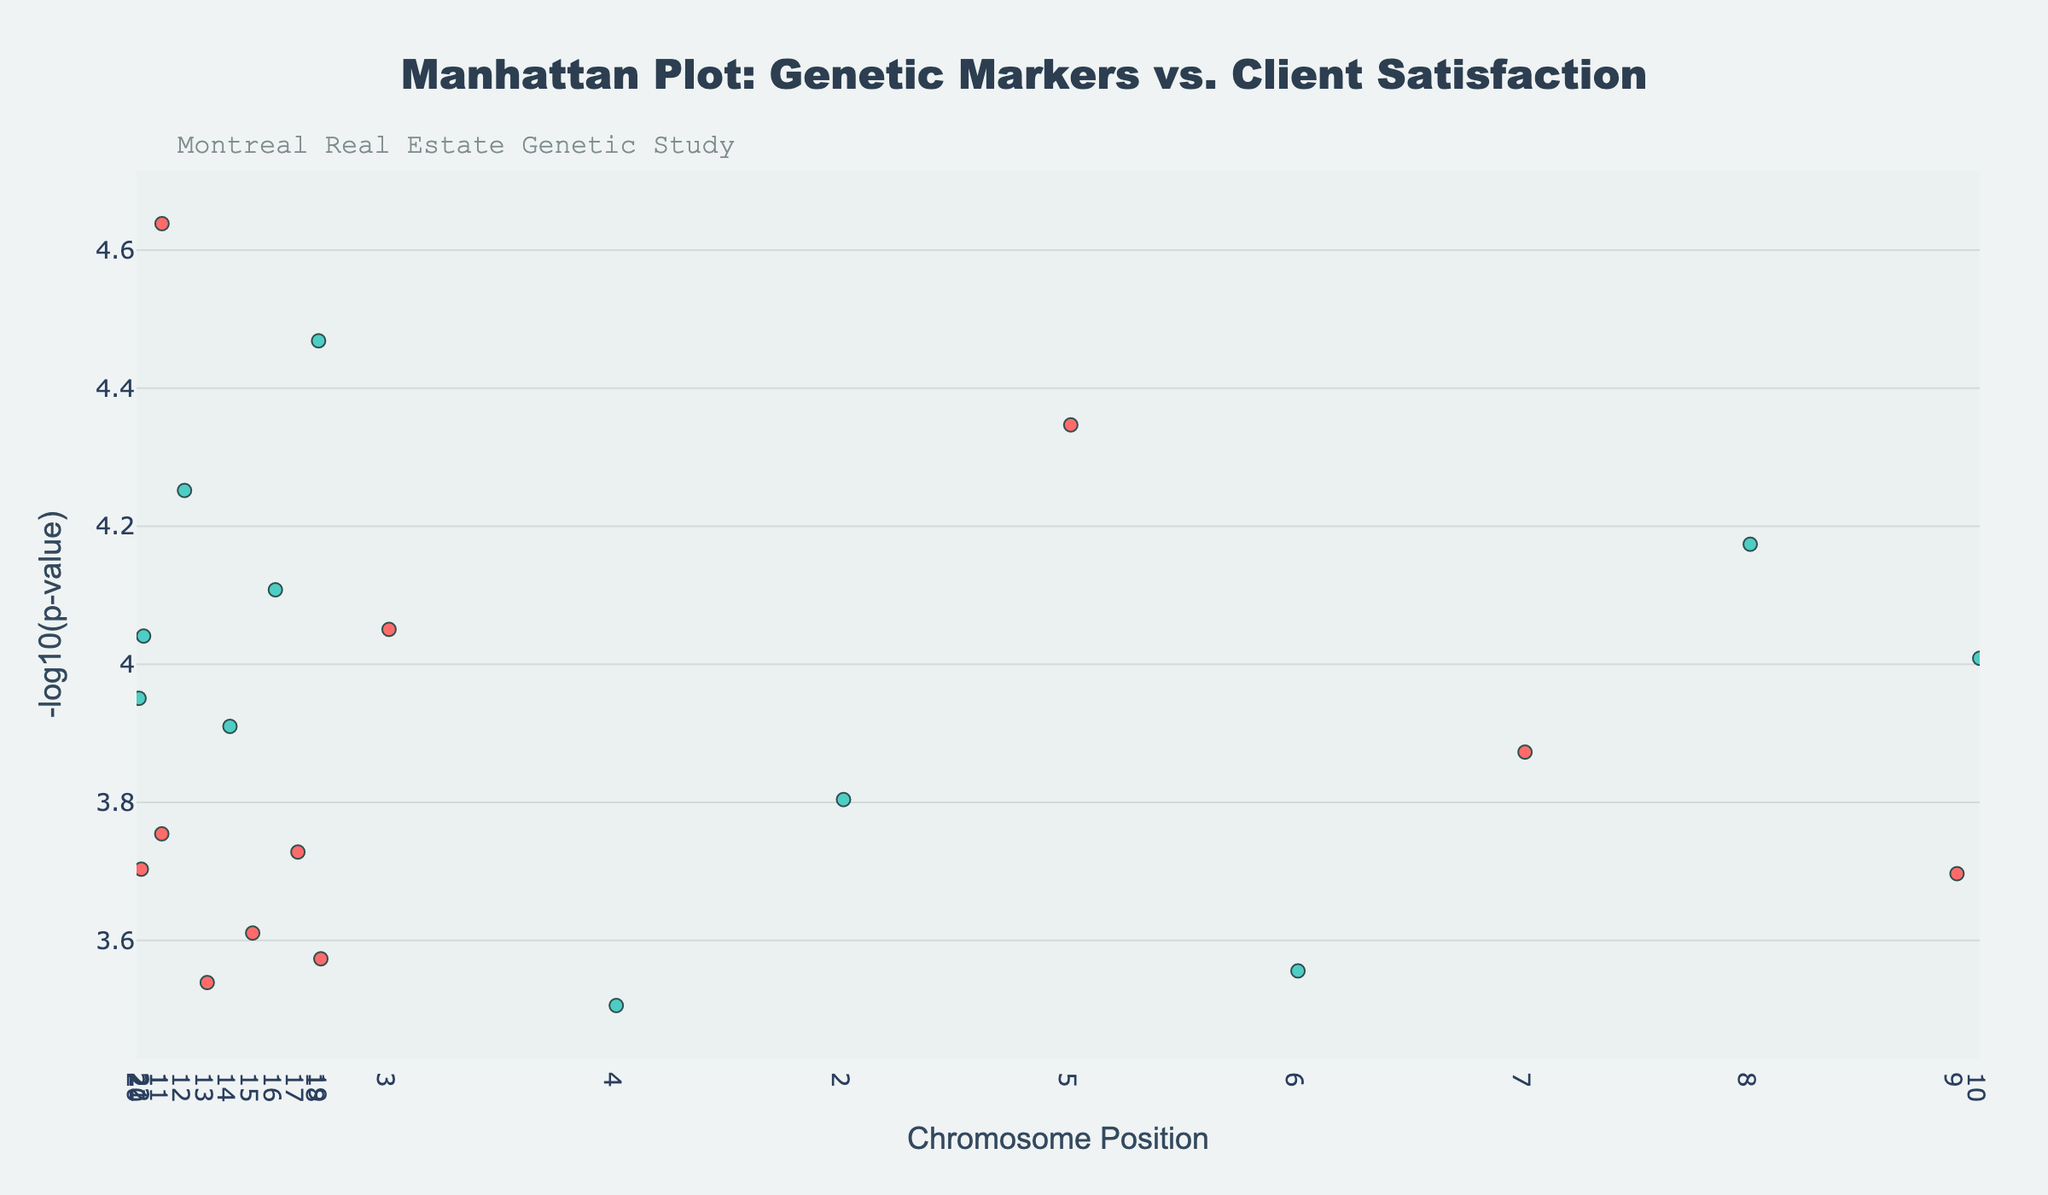Which chromosome has the highest number of data points? To find the chromosome with the highest number of data points, look at how many markers (SNPs) there are for each chromosome by counting the plotted points. The chromosome with the highest count has the most data points.
Answer: Chromosome 1 What is the highest -log10(p-value) and which chromosome does it belong to? To find the highest -log10(p-value), look at the vertical positions of the points and identify the highest one. Refer to the chromosome indicated by this point's color and position.
Answer: -log10(p-value) is 4.64, belongs to Chromosome 1 Which chromosome has the lowest average -log10(p-value)? Calculate the average -log10(p-value) for each chromosome by summing up and dividing by the number of data points for each chromosome. Identify the chromosome with the smallest average value.
Answer: Chromosome 15 How many chromosomes have at least one data point with a -log10(p-value) greater than 4? Count the number of chromosomes that have at least one point above the -log10(p-value) of 4 by visually inspecting the vertical positions and identifying the chromosomes.
Answer: 4 chromosomes What is the SNP with the lowest P-value and what chromosome is it on? Identify the lowest P-value using the -log10 scale (highest vertical point), then refer to the SNP name in the hovertext and the chromosome it belongs to.
Answer: SNP 'rs2341567' on Chromosome 1 What is the range of chromosome positions on Chromosome 10? Find the minimum and maximum chromosome positions for Chromosome 10 by looking at the horizontal spread of points on Chromosome 10 and noting the smallest and largest values.
Answer: 90123456 Are there more markers on even or odd-numbered chromosomes? Count the number of markers (SNPs) for even-numbered chromosomes and odd-numbered chromosomes, then compare the totals.
Answer: Odd-numbered chromosomes Which chromosome has the SNP 'rs8765432' and how many such SNPs are there throughout the plot? Search for the SNP 'rs8765432' in the hovertext to identify its chromosome and count how many times 'rs8765432' appears in the plot.
Answer: Chromosome 4 and Two instances 